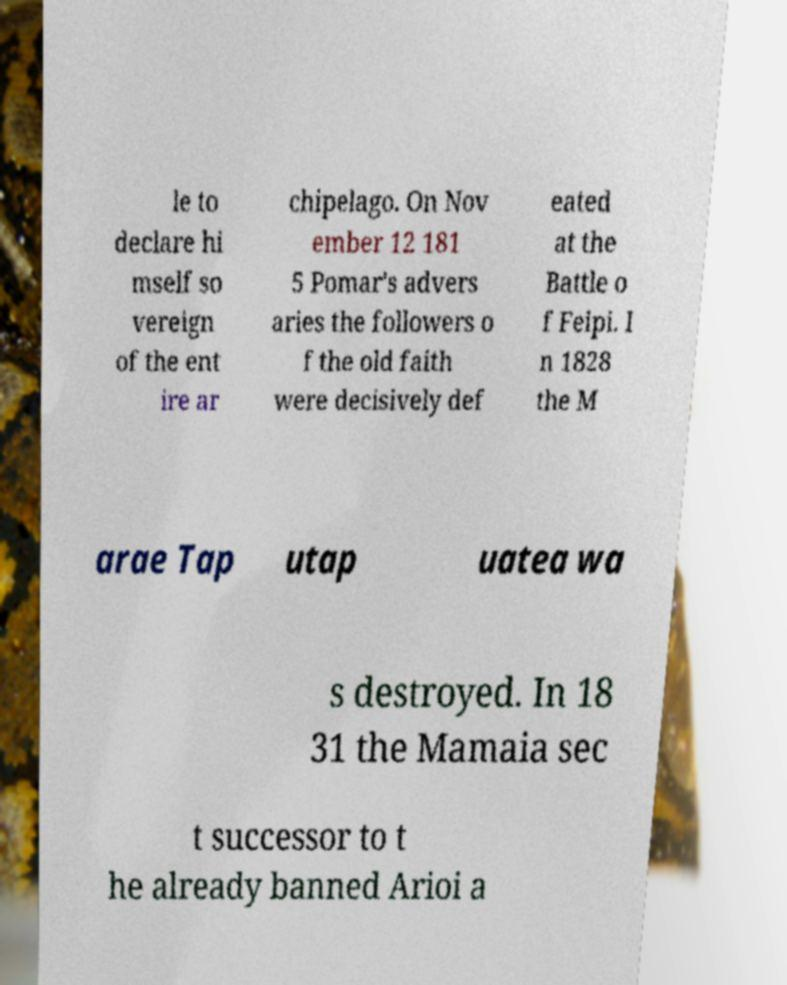Can you accurately transcribe the text from the provided image for me? le to declare hi mself so vereign of the ent ire ar chipelago. On Nov ember 12 181 5 Pomar's advers aries the followers o f the old faith were decisively def eated at the Battle o f Feipi. I n 1828 the M arae Tap utap uatea wa s destroyed. In 18 31 the Mamaia sec t successor to t he already banned Arioi a 